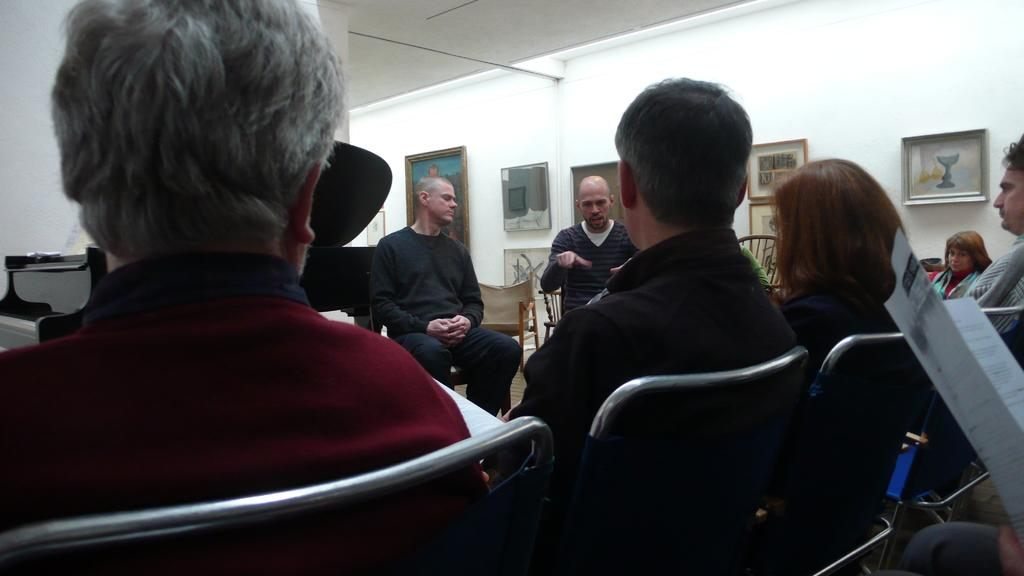What are the people in the image doing? There are many people sitting on chairs in the image. Can you describe the activity of the person on the right side? A person is holding a book on the right side. What can be seen in the background of the image? There is a wall with photo frames in the background. What type of railway is visible in the image? There is no railway present in the image. How does the comfort of the chairs affect the respect shown by the people in the image? The comfort of the chairs and the respect shown by the people are not related in the image, as there is no indication of the chairs' comfort or the people's respect for each other. 